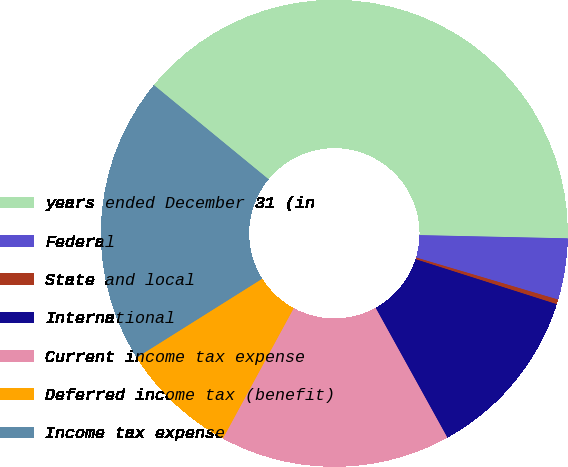Convert chart. <chart><loc_0><loc_0><loc_500><loc_500><pie_chart><fcel>years ended December 31 (in<fcel>Federal<fcel>State and local<fcel>International<fcel>Current income tax expense<fcel>Deferred income tax (benefit)<fcel>Income tax expense<nl><fcel>39.4%<fcel>4.24%<fcel>0.33%<fcel>12.05%<fcel>15.96%<fcel>8.15%<fcel>19.87%<nl></chart> 